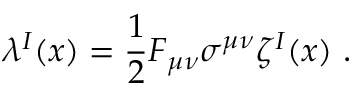Convert formula to latex. <formula><loc_0><loc_0><loc_500><loc_500>\lambda ^ { I } ( x ) = \frac { 1 } { 2 } F _ { \mu \nu } \sigma ^ { \mu \nu } \zeta ^ { I } ( x ) \ .</formula> 